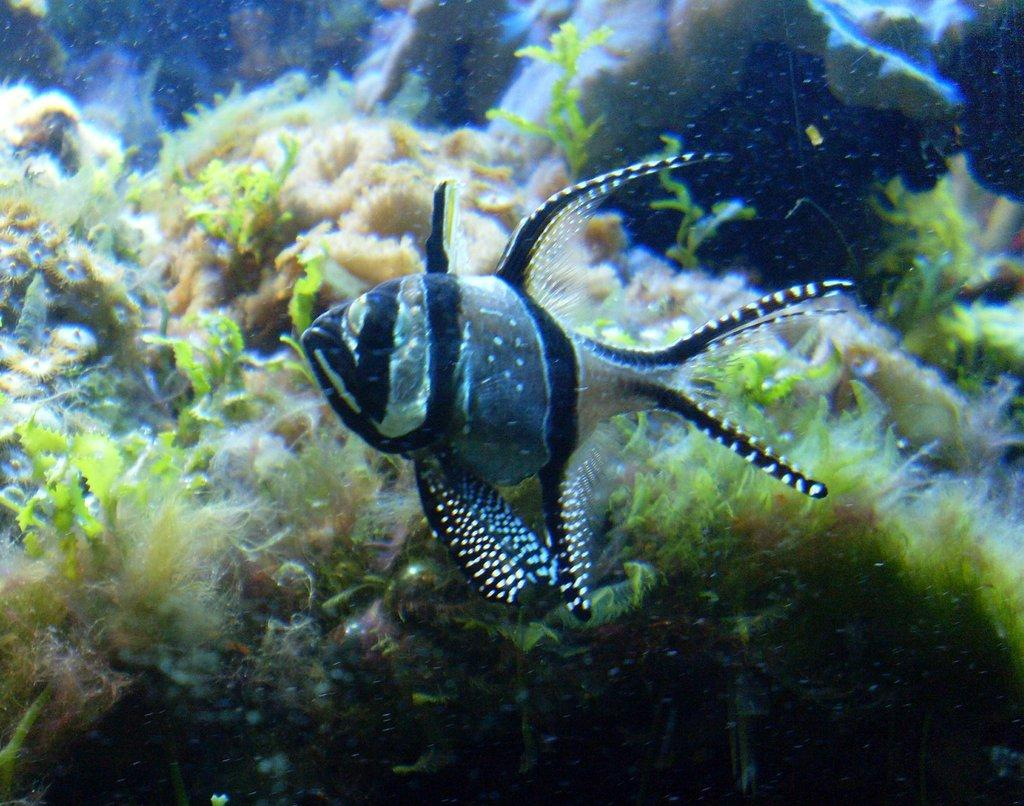What is the main subject of the image? The image depicts a water body. Are there any living creatures visible in the water body? Yes, there is a fish in the water body. Are there any plants in the water body? Yes, there are small plants in the water body. How many brothers does the fish in the image have? There is no information about the fish's family in the image, so we cannot determine how many brothers the fish has. 